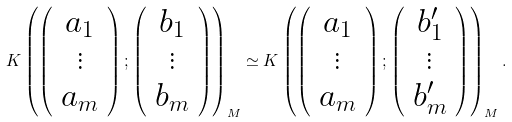<formula> <loc_0><loc_0><loc_500><loc_500>K \left ( \left ( \begin{array} { c } a _ { 1 } \\ \vdots \\ a _ { m } \end{array} \right ) ; \left ( \begin{array} { c } b _ { 1 } \\ \vdots \\ b _ { m } \end{array} \right ) \right ) _ { M } \simeq K \left ( \left ( \begin{array} { c } a _ { 1 } \\ \vdots \\ a _ { m } \end{array} \right ) ; \left ( \begin{array} { c } b _ { 1 } ^ { \prime } \\ \vdots \\ b _ { m } ^ { \prime } \end{array} \right ) \right ) _ { M } .</formula> 